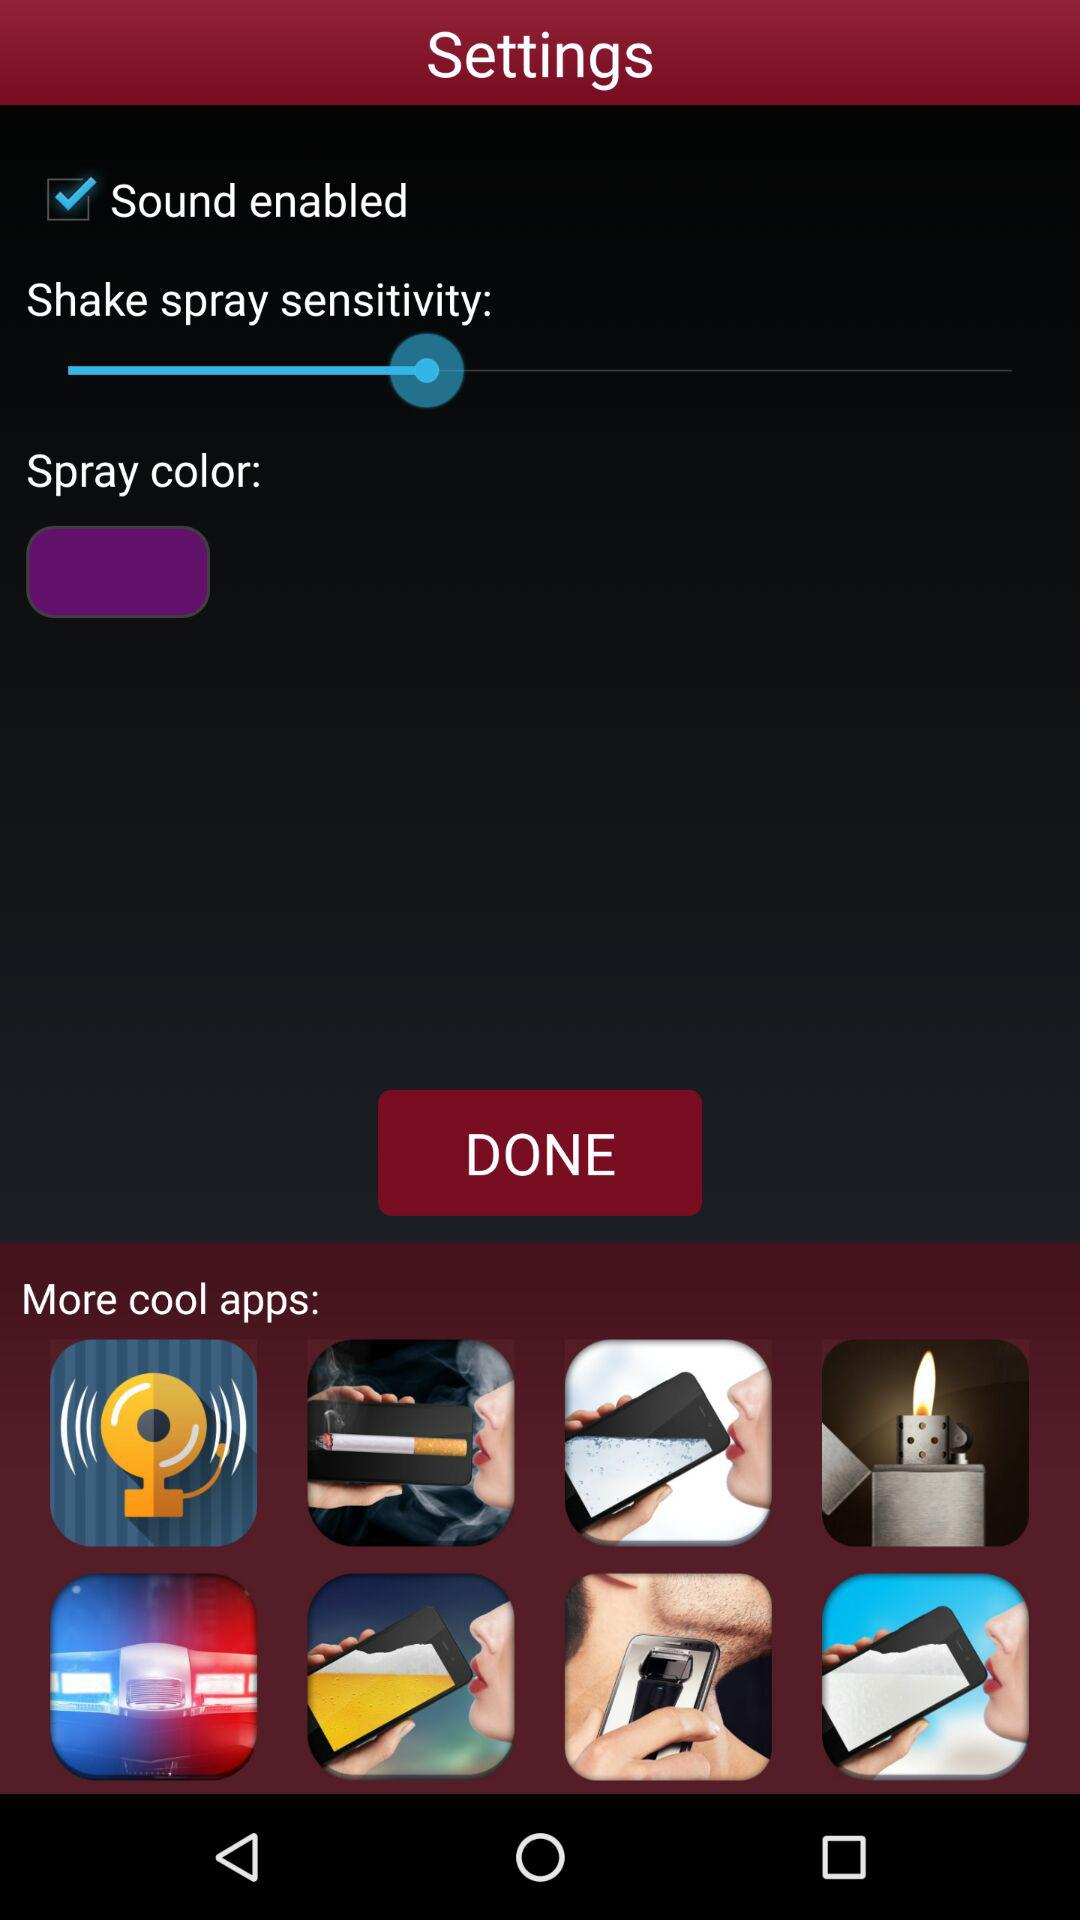What is the status of "Sound enabled"? The status is "on". 